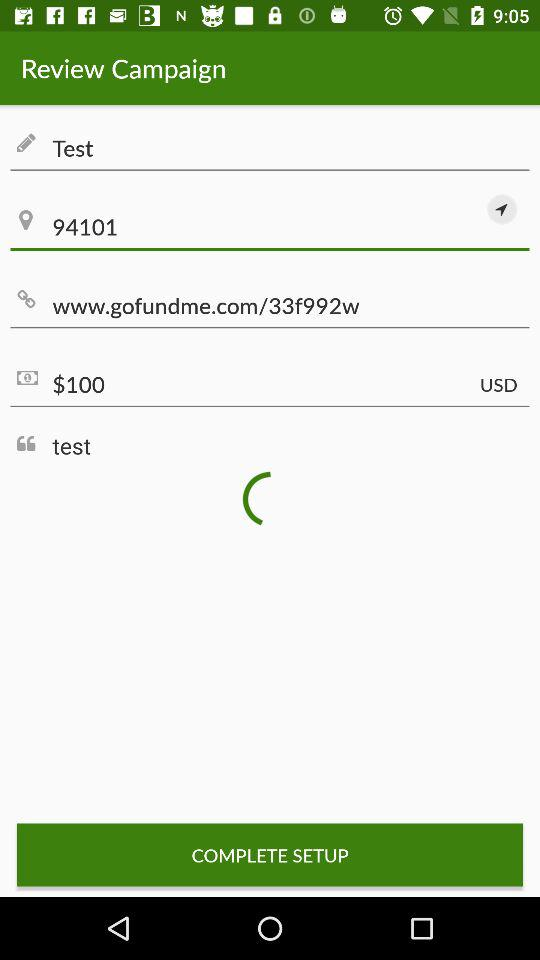What is the currency of price? The currency of price is USD. 